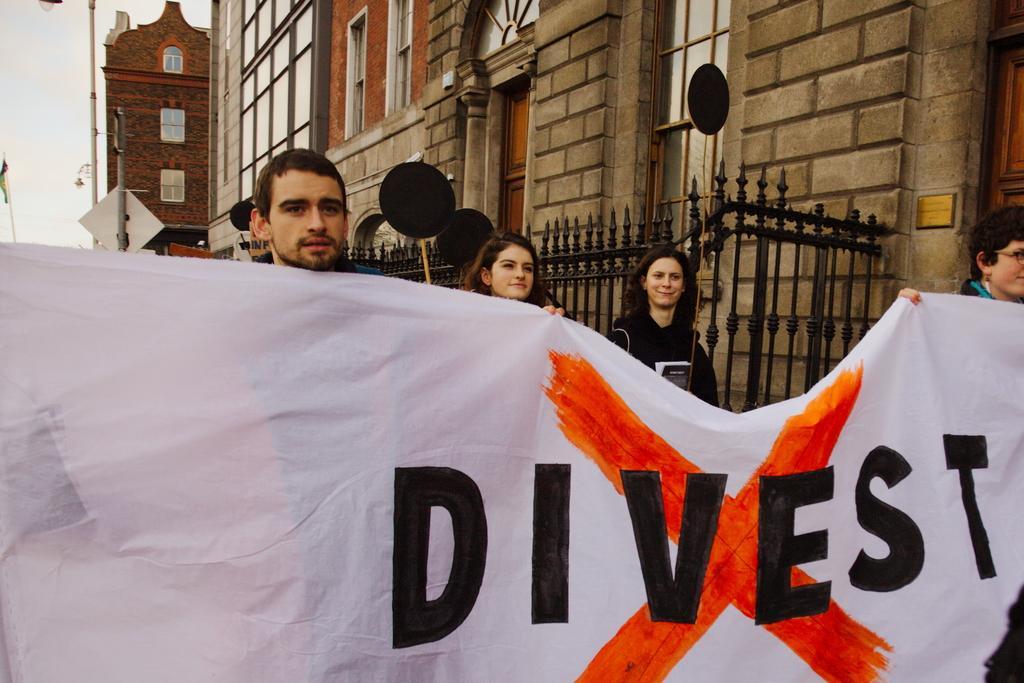Please provide a concise description of this image. In this picture there are people, among them two persons holding a banner and we can see boards, railing, poles, lights and buildings. In the background of the image we can see the sky. 